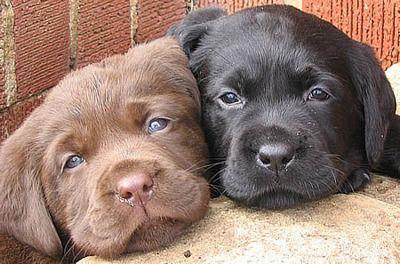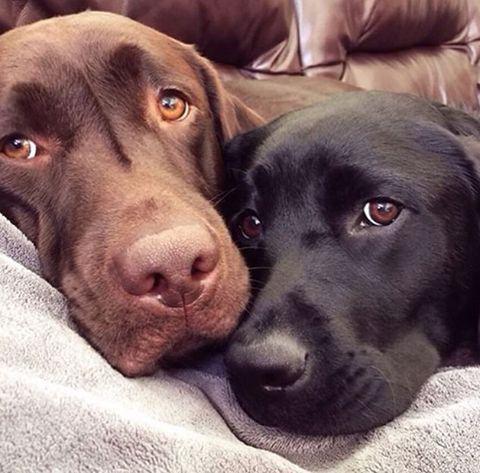The first image is the image on the left, the second image is the image on the right. Given the left and right images, does the statement "One picture shows a brown dog, a light cream dog, and a black dog next to each other, with the light dog in the middle." hold true? Answer yes or no. No. The first image is the image on the left, the second image is the image on the right. For the images displayed, is the sentence "There are the same number of dogs in each image, but they are a different age in one image than the other." factually correct? Answer yes or no. Yes. 